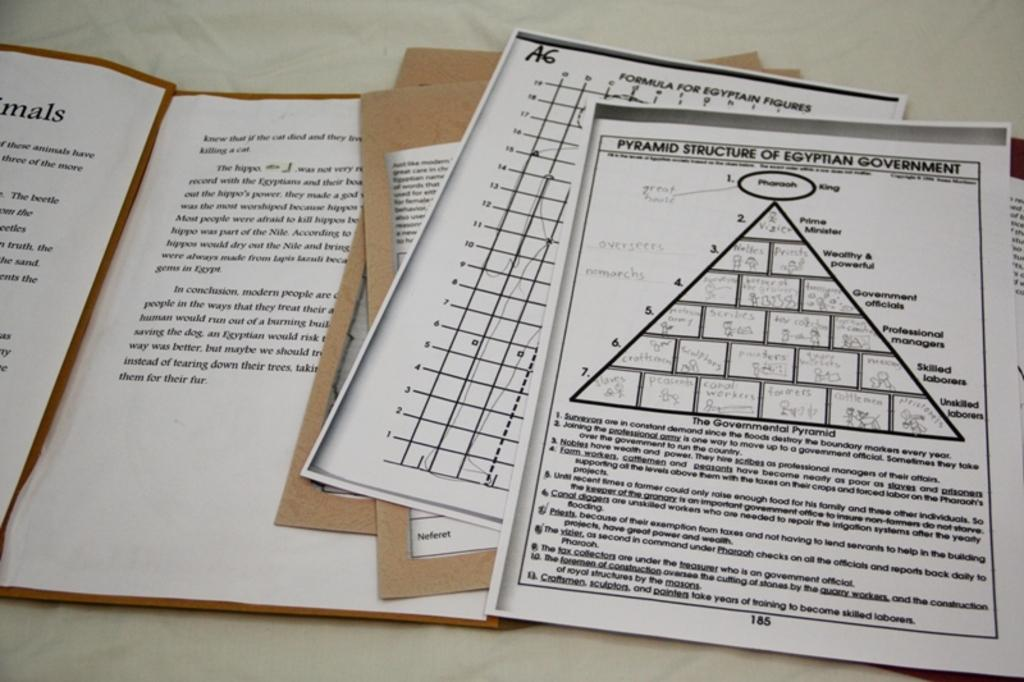What type of booklet is present in the image that has a pyramid structure? There is a pyramid structure booklet in the image. What other type of booklet can be seen in the image? There is a formula booklet in the image. How many other booklets are present in the image? There are two other booklets in the image. What is the fifth item in the image? There is a book in the image. On what surface are all the items placed? All items are placed on a plain surface. Where is the fireman in the image? There is no fireman present in the image. What color is the umbrella in the image? There is no umbrella present in the image. 